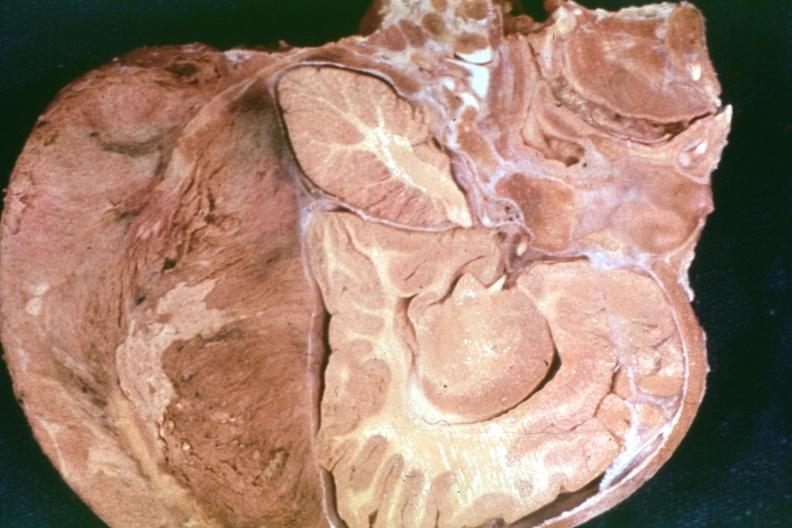s metastatic carcinoma lung present?
Answer the question using a single word or phrase. No 